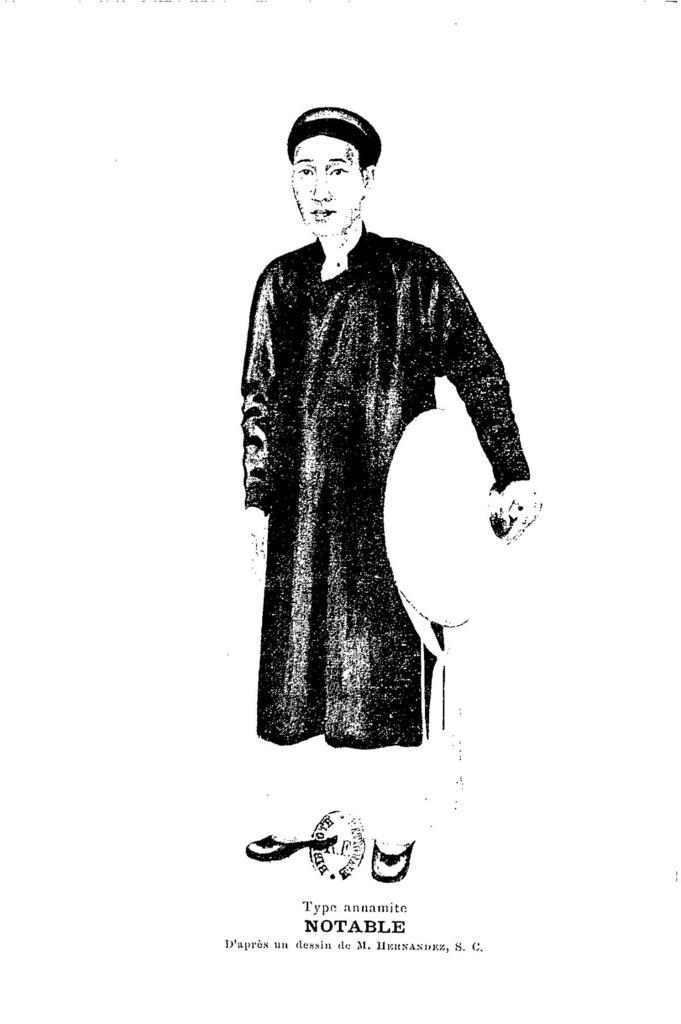Please provide a concise description of this image. In this image, we can see a sketch of a person and there is some text. 